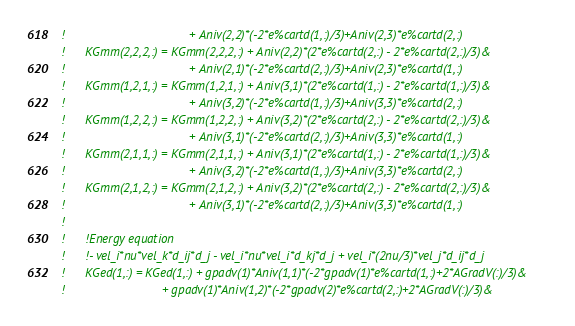Convert code to text. <code><loc_0><loc_0><loc_500><loc_500><_FORTRAN_>!                                    + Aniv(2,2)*(-2*e%cartd(1,:)/3)+Aniv(2,3)*e%cartd(2,:) 
!      KGmm(2,2,2,:) = KGmm(2,2,2,:) + Aniv(2,2)*(2*e%cartd(2,:) - 2*e%cartd(2,:)/3)&
!                                    + Aniv(2,1)*(-2*e%cartd(2,:)/3)+Aniv(2,3)*e%cartd(1,:) 
!      KGmm(1,2,1,:) = KGmm(1,2,1,:) + Aniv(3,1)*(2*e%cartd(1,:) - 2*e%cartd(1,:)/3)&  
!                                    + Aniv(3,2)*(-2*e%cartd(1,:)/3)+Aniv(3,3)*e%cartd(2,:) 
!      KGmm(1,2,2,:) = KGmm(1,2,2,:) + Aniv(3,2)*(2*e%cartd(2,:) - 2*e%cartd(2,:)/3)&
!                                    + Aniv(3,1)*(-2*e%cartd(2,:)/3)+Aniv(3,3)*e%cartd(1,:) 
!      KGmm(2,1,1,:) = KGmm(2,1,1,:) + Aniv(3,1)*(2*e%cartd(1,:) - 2*e%cartd(1,:)/3)&  
!                                    + Aniv(3,2)*(-2*e%cartd(1,:)/3)+Aniv(3,3)*e%cartd(2,:) 
!      KGmm(2,1,2,:) = KGmm(2,1,2,:) + Aniv(3,2)*(2*e%cartd(2,:) - 2*e%cartd(2,:)/3)&
!                                    + Aniv(3,1)*(-2*e%cartd(2,:)/3)+Aniv(3,3)*e%cartd(1,:) 
!
!      !Energy equation
!      !- vel_i*nu*vel_k*d_ij*d_j - vel_i*nu*vel_i*d_kj*d_j + vel_i*(2nu/3)*vel_j*d_ij*d_j
!      KGed(1,:) = KGed(1,:) + gpadv(1)*Aniv(1,1)*(-2*gpadv(1)*e%cartd(1,:)+2*AGradV(:)/3)&
!                            + gpadv(1)*Aniv(1,2)*(-2*gpadv(2)*e%cartd(2,:)+2*AGradV(:)/3)&</code> 